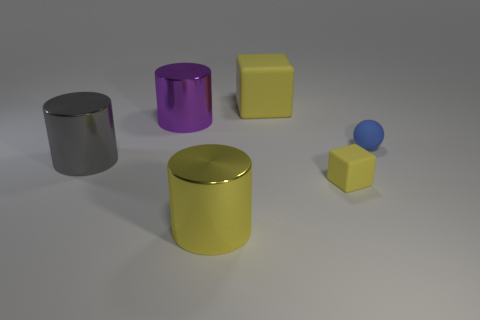What size is the metal object that is the same color as the big rubber object?
Give a very brief answer. Large. There is a cylinder in front of the big gray metal cylinder; what size is it?
Make the answer very short. Large. Is there a metal cylinder that has the same color as the small matte cube?
Offer a very short reply. Yes. There is a yellow block that is on the right side of the large block; is there a yellow object left of it?
Keep it short and to the point. Yes. Does the purple shiny cylinder have the same size as the rubber cube behind the gray cylinder?
Your response must be concise. Yes. Are there any yellow objects that are on the left side of the rubber block that is in front of the big thing on the right side of the large yellow metal cylinder?
Give a very brief answer. Yes. There is a cube that is in front of the large yellow matte object; what is it made of?
Keep it short and to the point. Rubber. Do the gray object and the blue matte object have the same size?
Offer a terse response. No. There is a big cylinder that is to the right of the gray thing and in front of the purple metallic cylinder; what is its color?
Provide a short and direct response. Yellow. There is a yellow object that is the same material as the big gray object; what shape is it?
Offer a very short reply. Cylinder. 